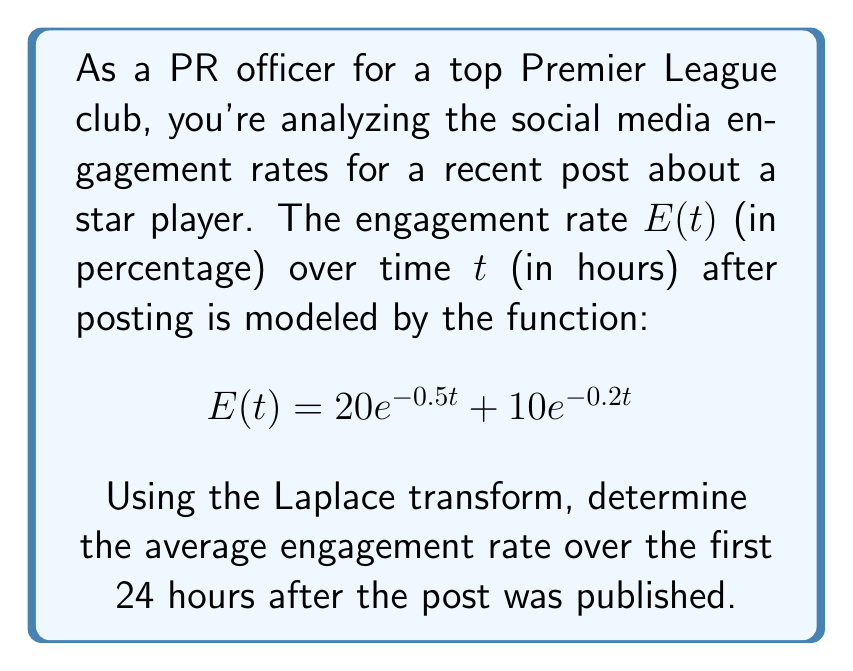Help me with this question. To solve this problem, we'll follow these steps:

1) First, let's recall the formula for the average value of a function $f(t)$ over an interval $[0,T]$:

   $$\text{Average} = \frac{1}{T}\int_0^T f(t) dt$$

2) In our case, $f(t) = E(t) = 20e^{-0.5t} + 10e^{-0.2t}$ and $T = 24$ hours.

3) We can use the Laplace transform to simplify the integration. The Laplace transform of $E(t)$ is:

   $$\mathcal{L}\{E(t)\} = \frac{20}{s+0.5} + \frac{10}{s+0.2}$$

4) The integral of $E(t)$ from 0 to T is related to the Laplace transform as follows:

   $$\int_0^T E(t) dt = \mathcal{L}\{E(t)\}\Big|_{s=0} - \mathcal{L}\{E(t)e^{-sT}\}\Big|_{s=0}$$

5) Let's calculate these terms:

   $$\mathcal{L}\{E(t)\}\Big|_{s=0} = \frac{20}{0+0.5} + \frac{10}{0+0.2} = 40 + 50 = 90$$

   $$\mathcal{L}\{E(t)e^{-sT}\}\Big|_{s=0} = \frac{20e^{-0.5T}}{0+0.5} + \frac{10e^{-0.2T}}{0+0.2} = 40e^{-0.5T} + 50e^{-0.2T}$$

6) Substituting $T = 24$:

   $$\int_0^{24} E(t) dt = 90 - (40e^{-12} + 50e^{-4.8})$$

7) Now we can calculate the average:

   $$\text{Average} = \frac{1}{24}[90 - (40e^{-12} + 50e^{-4.8})]$$

8) Evaluating this expression:

   $$\text{Average} \approx 3.75\%$$
Answer: The average engagement rate over the first 24 hours after the post was published is approximately 3.75%. 